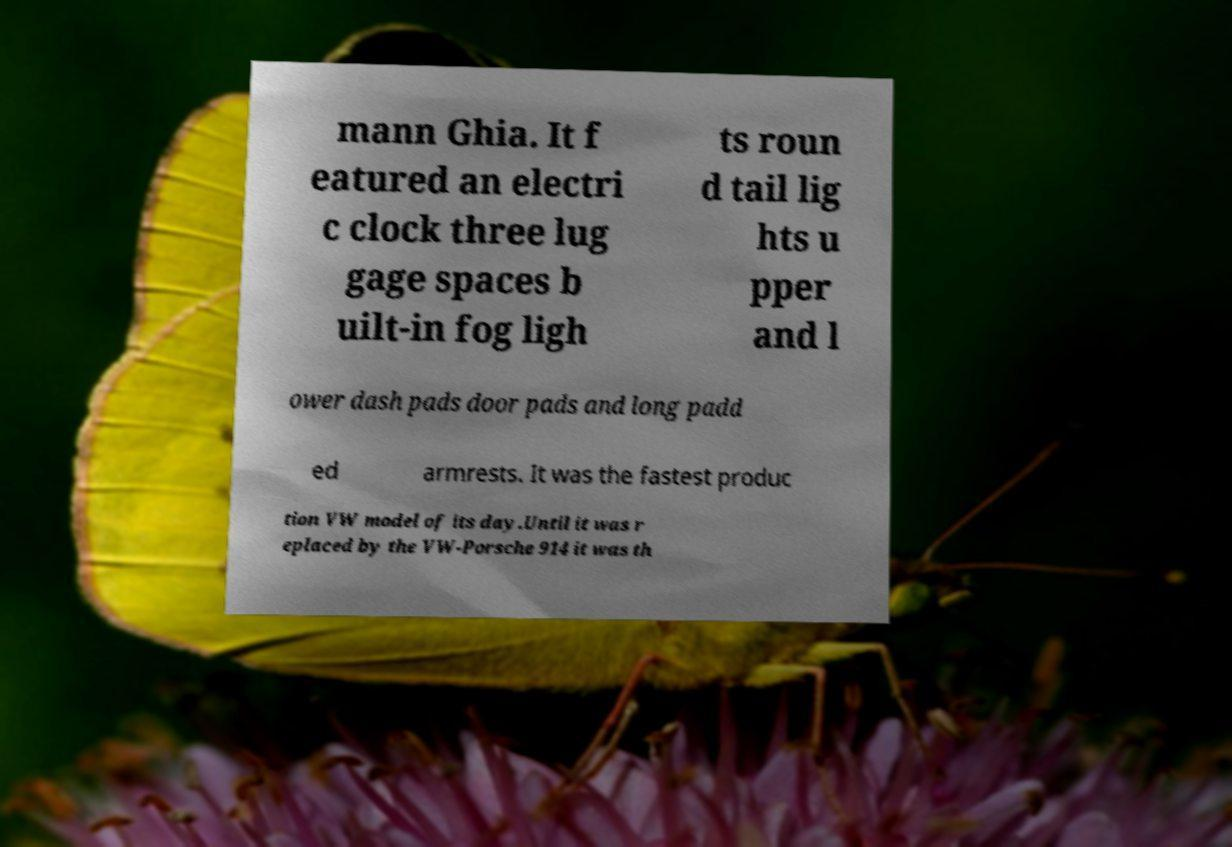Could you extract and type out the text from this image? mann Ghia. It f eatured an electri c clock three lug gage spaces b uilt-in fog ligh ts roun d tail lig hts u pper and l ower dash pads door pads and long padd ed armrests. It was the fastest produc tion VW model of its day.Until it was r eplaced by the VW-Porsche 914 it was th 